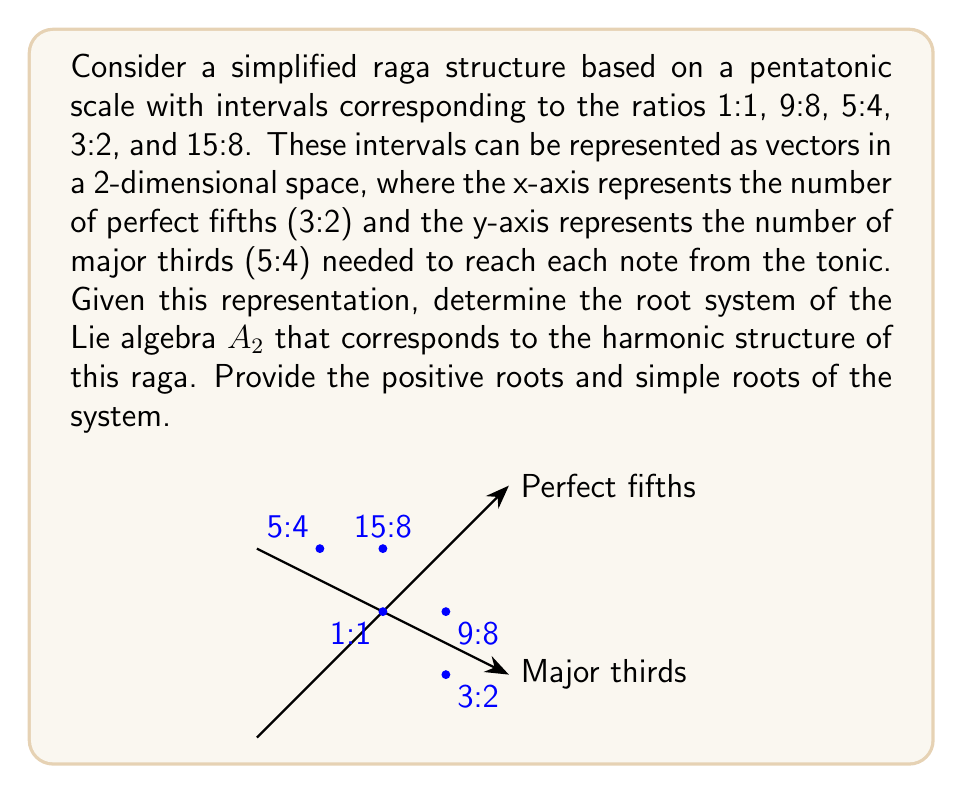What is the answer to this math problem? Let's approach this step-by-step:

1) First, we need to represent the intervals as vectors in our 2D space:
   - 1:1 (tonic): $(0,0)$
   - 9:8 (whole tone): $(2,-1)$
   - 5:4 (major third): $(-1,1)$
   - 3:2 (perfect fifth): $(1,-1)$
   - 15:8 (major seventh): $(0,1)$

2) The Lie algebra $A_2$ corresponds to $SU(3)$, which has a root system with 6 roots in total: 3 positive roots and 3 negative roots.

3) In our 2D representation, the positive roots of $A_2$ correspond to the vectors connecting the notes of our raga:
   $\alpha_1 = (1,-1)$ (perfect fifth)
   $\alpha_2 = (-1,1)$ (major third)
   $\alpha_1 + \alpha_2 = (0,1)$ (major seventh)

4) These three vectors form the positive roots of our root system. The negative roots are just the negatives of these vectors.

5) The simple roots are the vectors that cannot be written as a positive linear combination of other positive roots. In this case, the simple roots are:
   $\alpha_1 = (1,-1)$ and $\alpha_2 = (-1,1)$

6) We can verify that $\alpha_1 + \alpha_2 = (0,1)$, which is indeed the third positive root.

7) This root system forms an equilateral triangle in our 2D space, which is characteristic of the $A_2$ Lie algebra.
Answer: Positive roots: $\{(1,-1), (-1,1), (0,1)\}$
Simple roots: $\{(1,-1), (-1,1)\}$ 